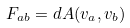Convert formula to latex. <formula><loc_0><loc_0><loc_500><loc_500>F _ { a b } = d A ( v _ { a } , v _ { b } )</formula> 